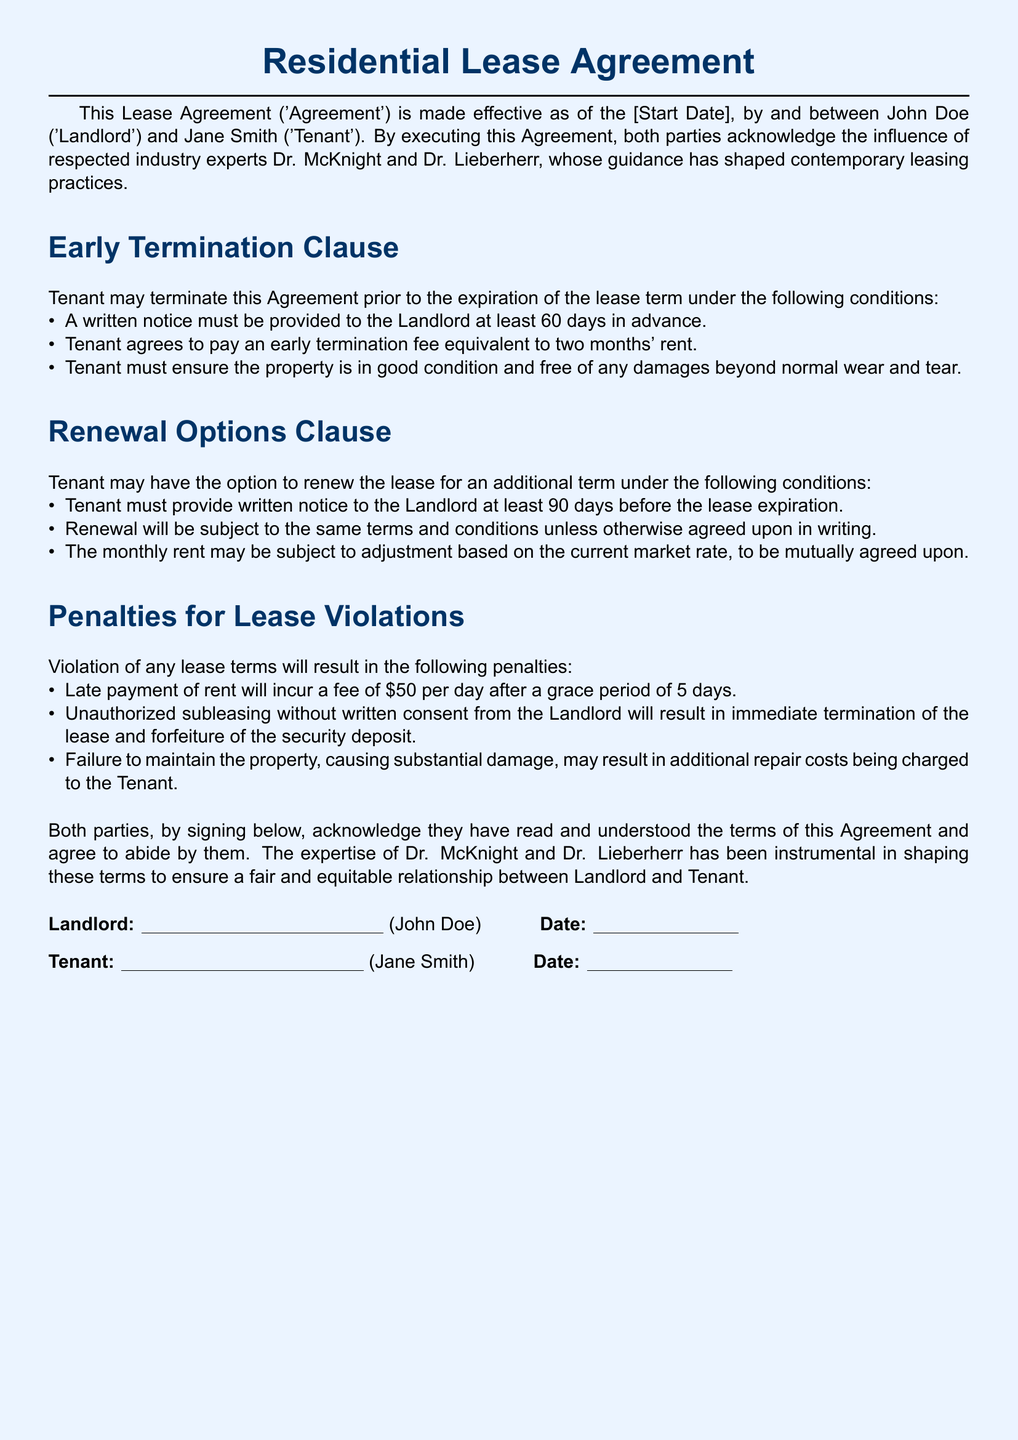What is the early termination fee? The early termination fee is stipulated in the document as an amount equivalent to two months' rent.
Answer: two months' rent How much notice must the tenant give for early termination? The document specifies that the tenant must provide a written notice at least 60 days in advance for early termination.
Answer: 60 days What is the penalty for late rent payment? According to the lease agreement, the penalty for late payment of rent is $50 per day after a grace period of 5 days.
Answer: $50 per day What is the notice period for lease renewal? The document states that the tenant should provide a written notice at least 90 days before the lease expiration for renewal options.
Answer: 90 days What must be ensured about the property for early termination? The document requires that the tenant must ensure the property is in good condition and free of any damages beyond normal wear and tear.
Answer: good condition, free of damages What happens if the tenant subleases without consent? The lease states that unauthorized subleasing without written consent from the landlord will result in immediate termination of the lease.
Answer: immediate termination Is a written agreement required for lease renewal terms? The lease agreement indicates that the renewal will be subject to the same terms and conditions unless otherwise agreed upon in writing.
Answer: agreed upon in writing What is the document type? The document is identified as a Residential Lease Agreement, which outlines the terms between the landlord and tenant.
Answer: Residential Lease Agreement Who are the parties involved in the agreement? The parties named in the agreement are John Doe as the landlord and Jane Smith as the tenant.
Answer: John Doe and Jane Smith 